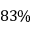Convert formula to latex. <formula><loc_0><loc_0><loc_500><loc_500>8 3 \%</formula> 